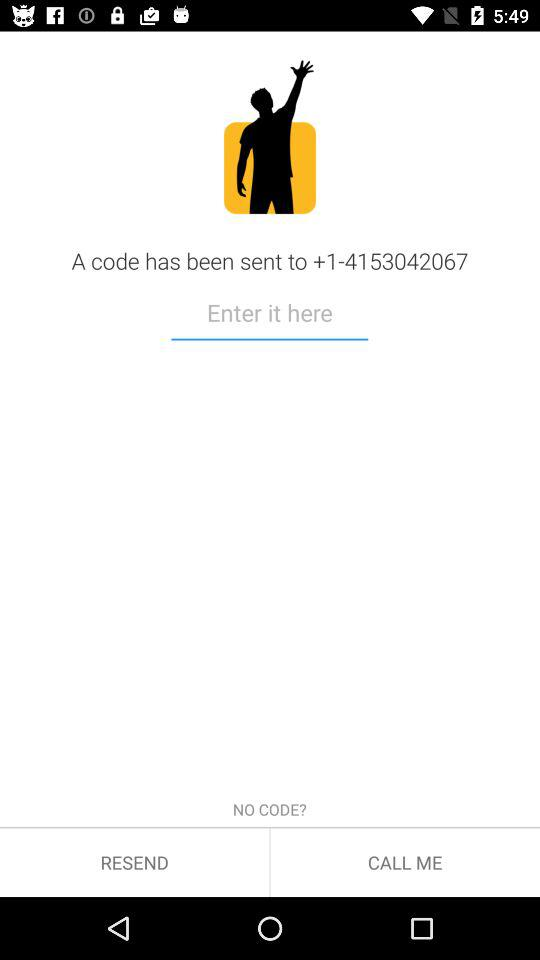What is the code?
When the provided information is insufficient, respond with <no answer>. <no answer> 